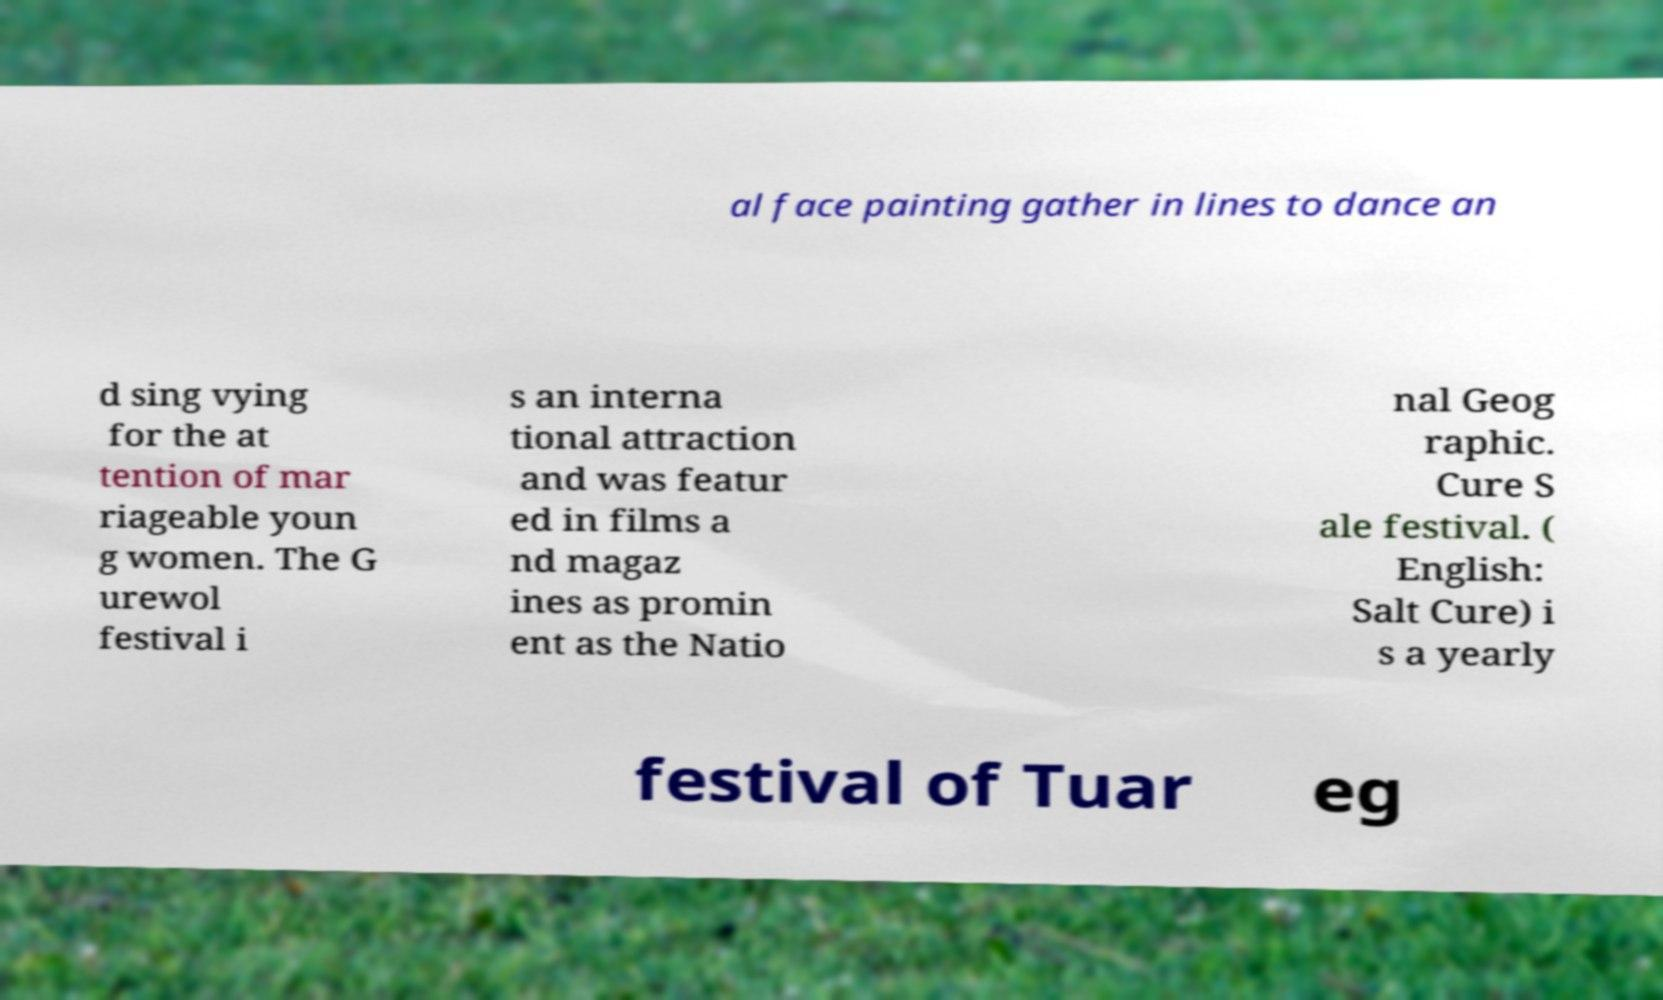Can you read and provide the text displayed in the image?This photo seems to have some interesting text. Can you extract and type it out for me? al face painting gather in lines to dance an d sing vying for the at tention of mar riageable youn g women. The G urewol festival i s an interna tional attraction and was featur ed in films a nd magaz ines as promin ent as the Natio nal Geog raphic. Cure S ale festival. ( English: Salt Cure) i s a yearly festival of Tuar eg 